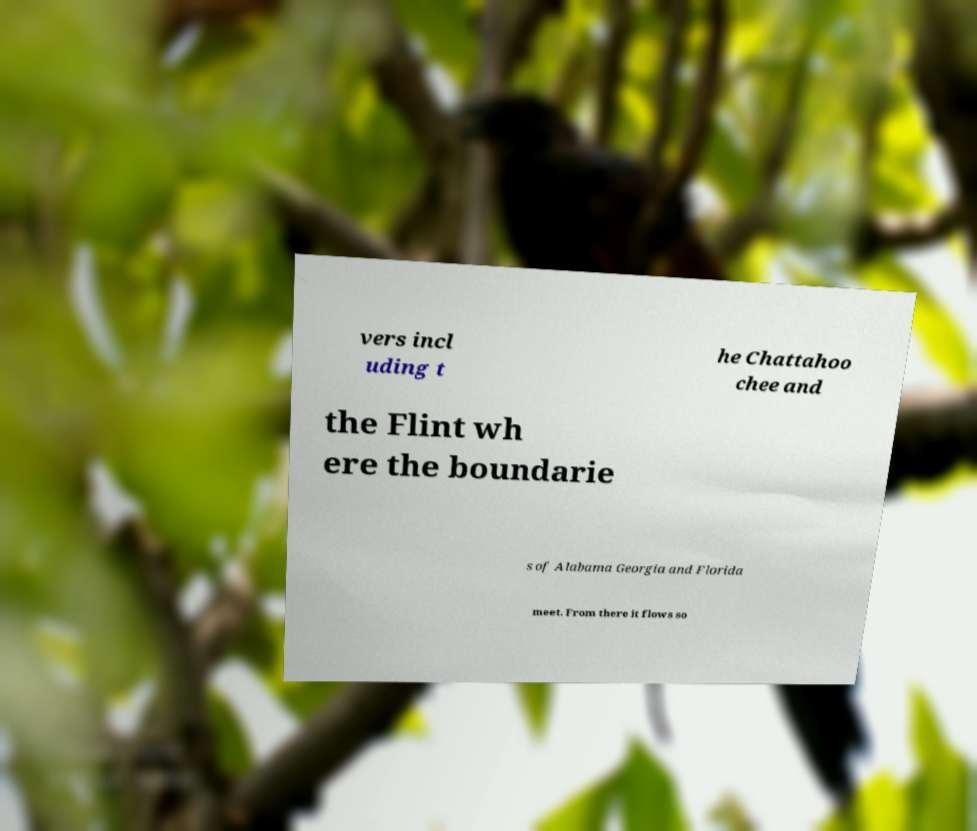What messages or text are displayed in this image? I need them in a readable, typed format. vers incl uding t he Chattahoo chee and the Flint wh ere the boundarie s of Alabama Georgia and Florida meet. From there it flows so 